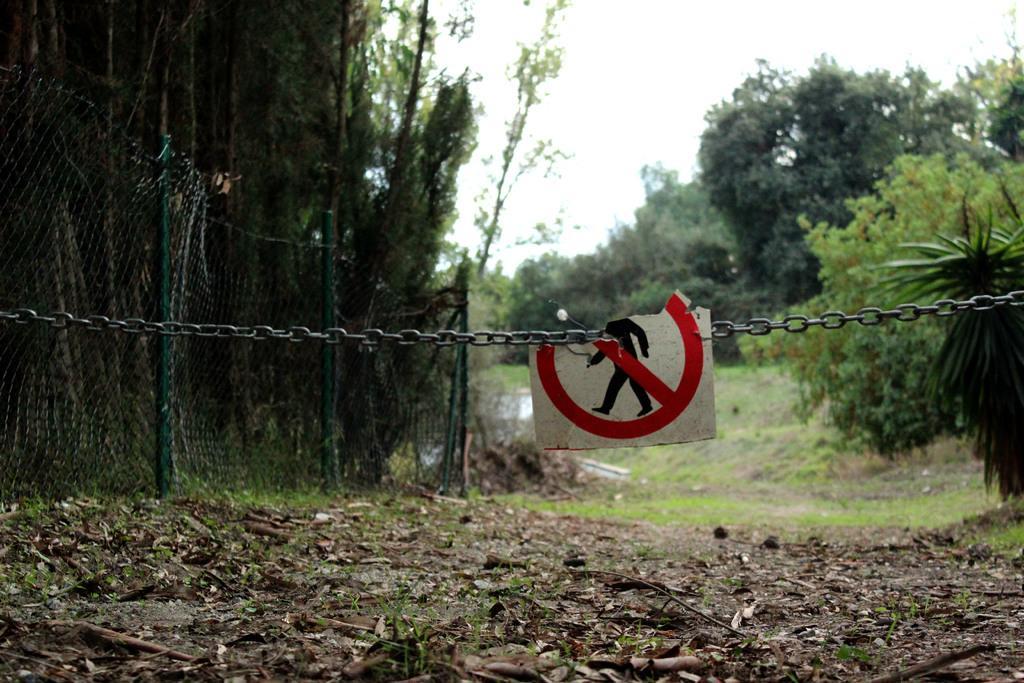Please provide a concise description of this image. In this image I can see the board attached to the chain. To the left I can see the fence. There are many trees and the white sky in the back. 